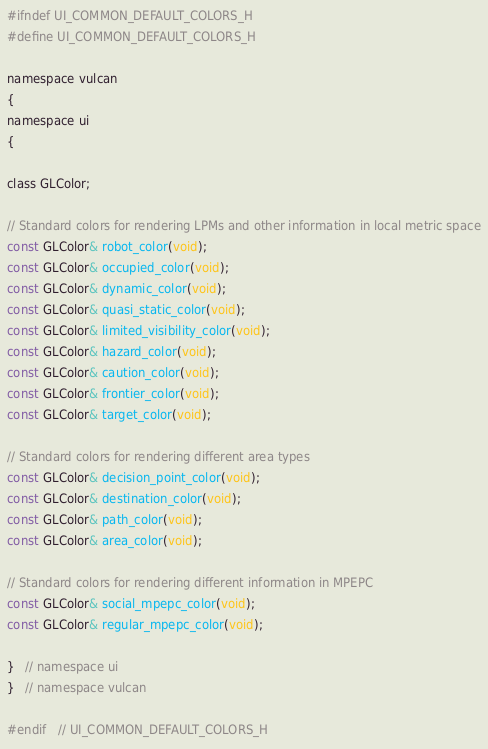Convert code to text. <code><loc_0><loc_0><loc_500><loc_500><_C_>#ifndef UI_COMMON_DEFAULT_COLORS_H
#define UI_COMMON_DEFAULT_COLORS_H

namespace vulcan
{
namespace ui
{

class GLColor;

// Standard colors for rendering LPMs and other information in local metric space
const GLColor& robot_color(void);
const GLColor& occupied_color(void);
const GLColor& dynamic_color(void);
const GLColor& quasi_static_color(void);
const GLColor& limited_visibility_color(void);
const GLColor& hazard_color(void);
const GLColor& caution_color(void);
const GLColor& frontier_color(void);
const GLColor& target_color(void);

// Standard colors for rendering different area types
const GLColor& decision_point_color(void);
const GLColor& destination_color(void);
const GLColor& path_color(void);
const GLColor& area_color(void);

// Standard colors for rendering different information in MPEPC
const GLColor& social_mpepc_color(void);
const GLColor& regular_mpepc_color(void);

}   // namespace ui
}   // namespace vulcan

#endif   // UI_COMMON_DEFAULT_COLORS_H
</code> 